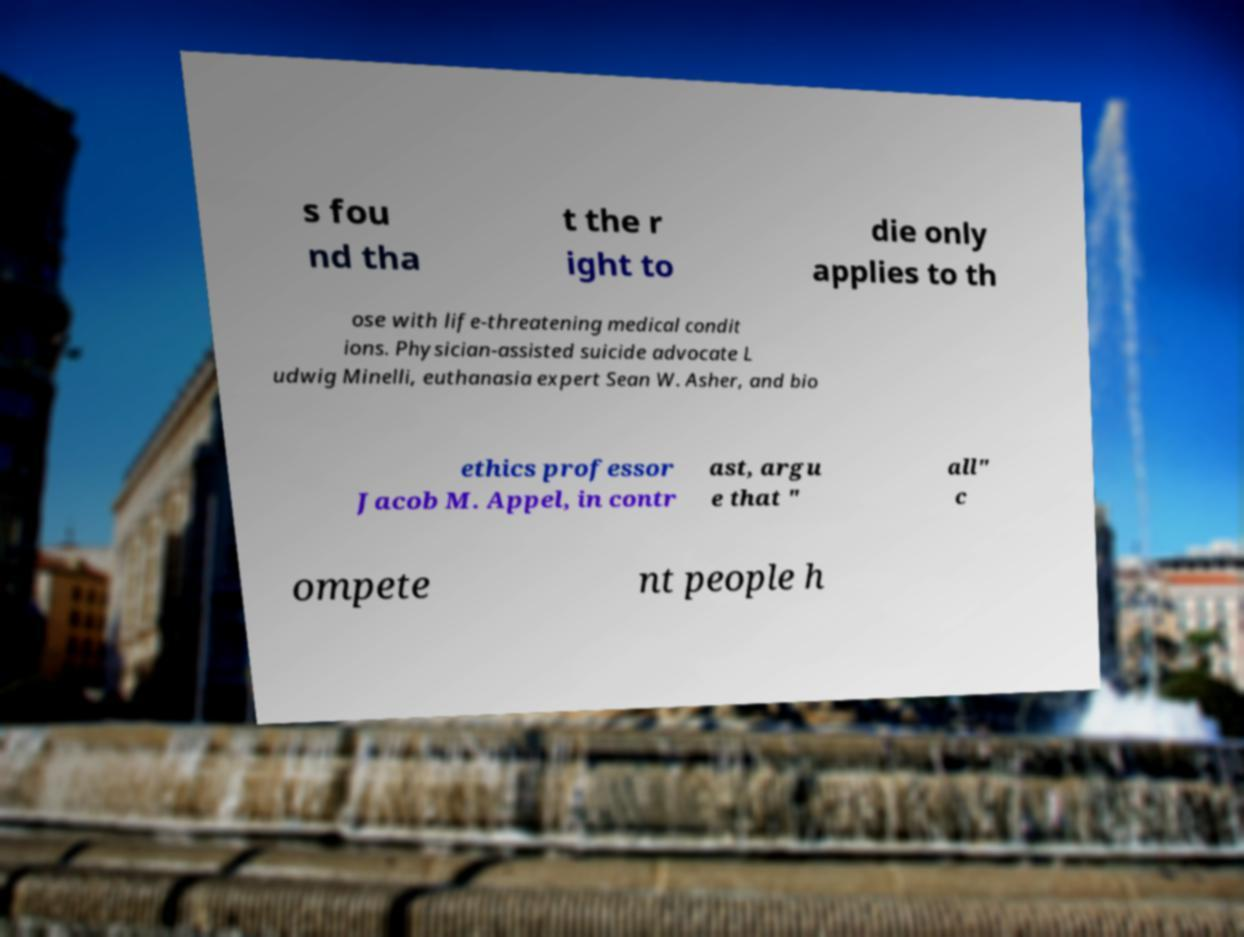Please identify and transcribe the text found in this image. s fou nd tha t the r ight to die only applies to th ose with life-threatening medical condit ions. Physician-assisted suicide advocate L udwig Minelli, euthanasia expert Sean W. Asher, and bio ethics professor Jacob M. Appel, in contr ast, argu e that " all" c ompete nt people h 